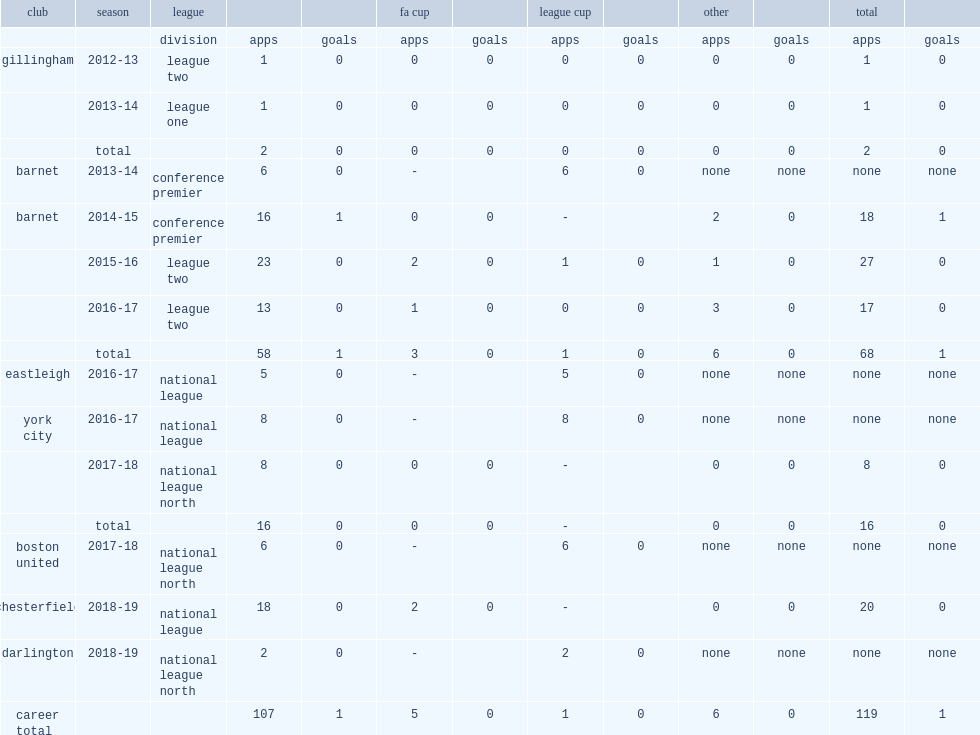Which club did muggleton play for in 2016-17? Eastleigh. 